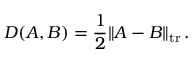<formula> <loc_0><loc_0><loc_500><loc_500>D ( A , B ) = { \frac { 1 } { 2 } } \| A - B \| _ { t r } \, .</formula> 